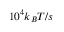Convert formula to latex. <formula><loc_0><loc_0><loc_500><loc_500>1 0 ^ { 4 } k _ { B } T / s</formula> 